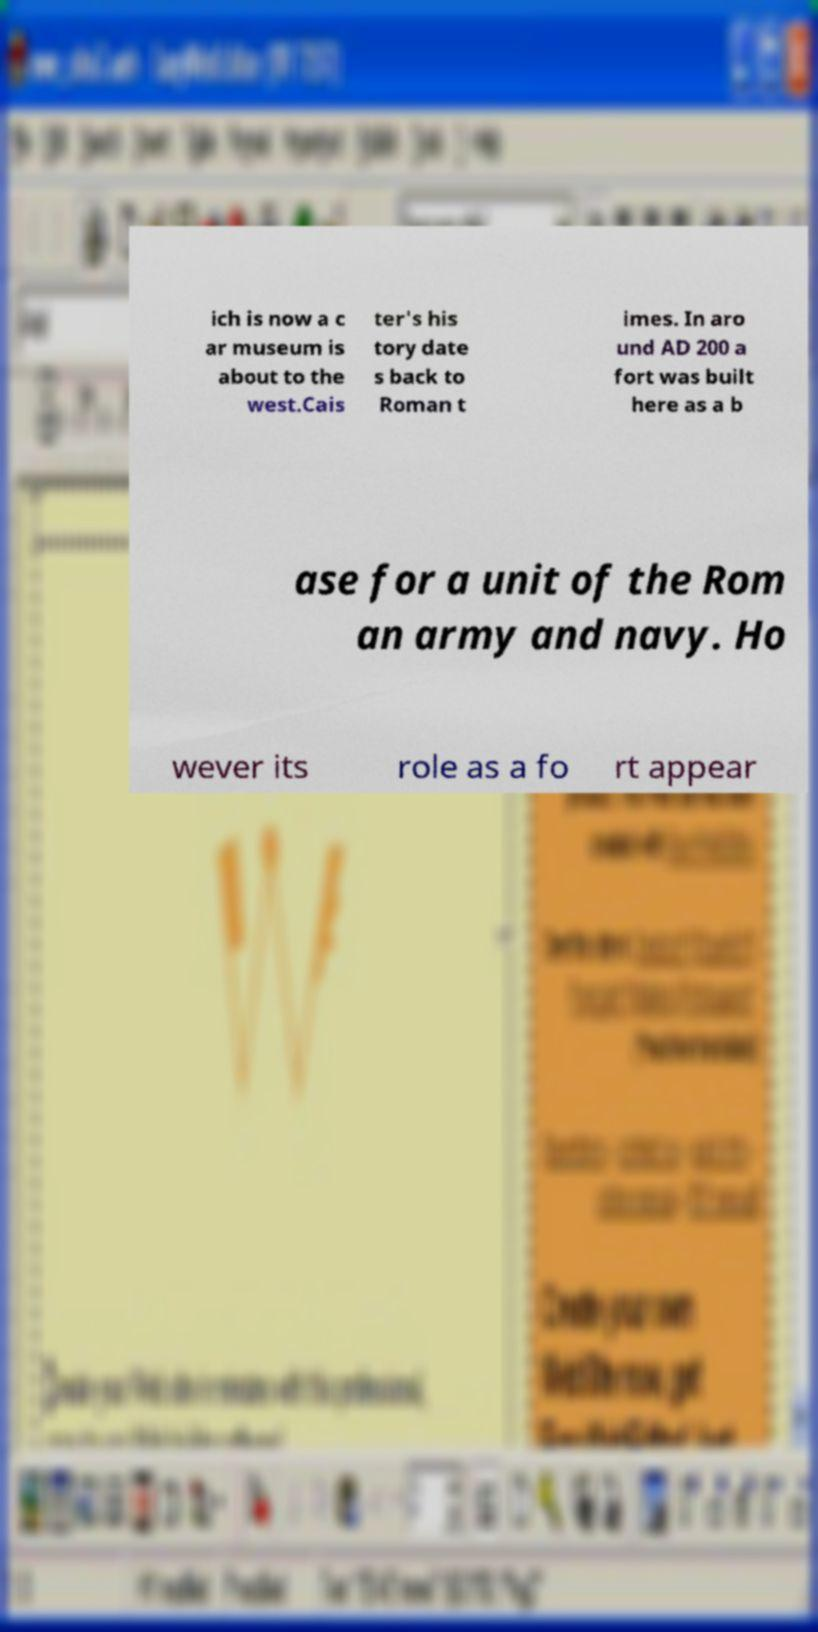Can you read and provide the text displayed in the image?This photo seems to have some interesting text. Can you extract and type it out for me? ich is now a c ar museum is about to the west.Cais ter's his tory date s back to Roman t imes. In aro und AD 200 a fort was built here as a b ase for a unit of the Rom an army and navy. Ho wever its role as a fo rt appear 